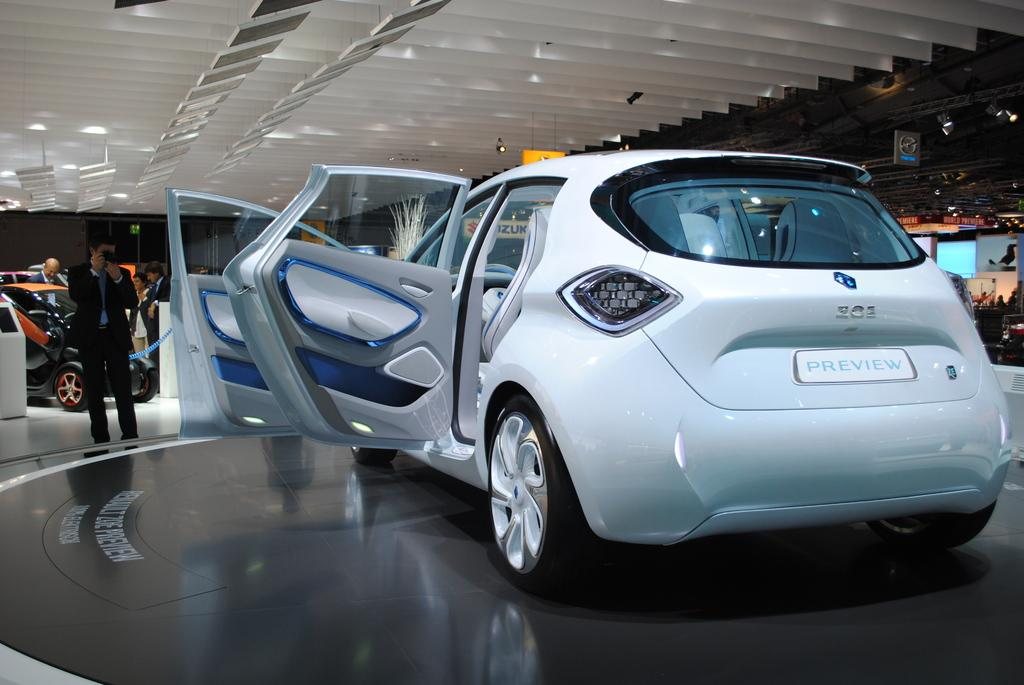What type of vehicle is in the image? There is a white car in the image. Who is present in the image besides the car? A man is standing on the left side of the car. What is the man doing in the image? The man is taking a photograph of the car. What is the man wearing in the image? The man is wearing a black coat. Can you tell me how many heads of lettuce are on the car in the image? There are no heads of lettuce present on the car in the image. Is there a farmer standing next to the car in the image? There is no farmer present in the image; only a man taking a photograph of the car is visible. 